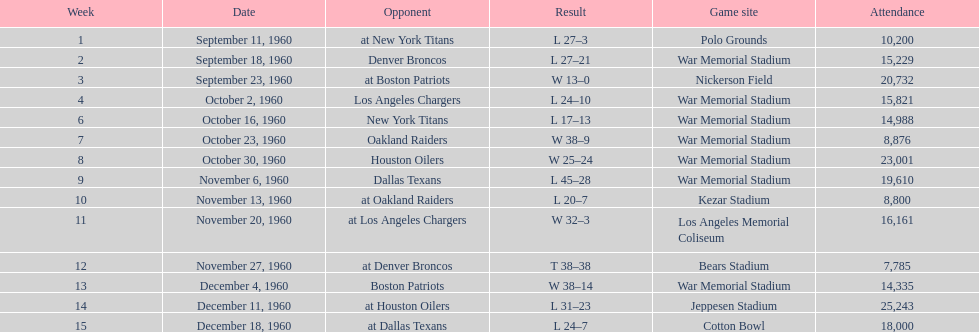Who was the adversary in the first week? New York Titans. 